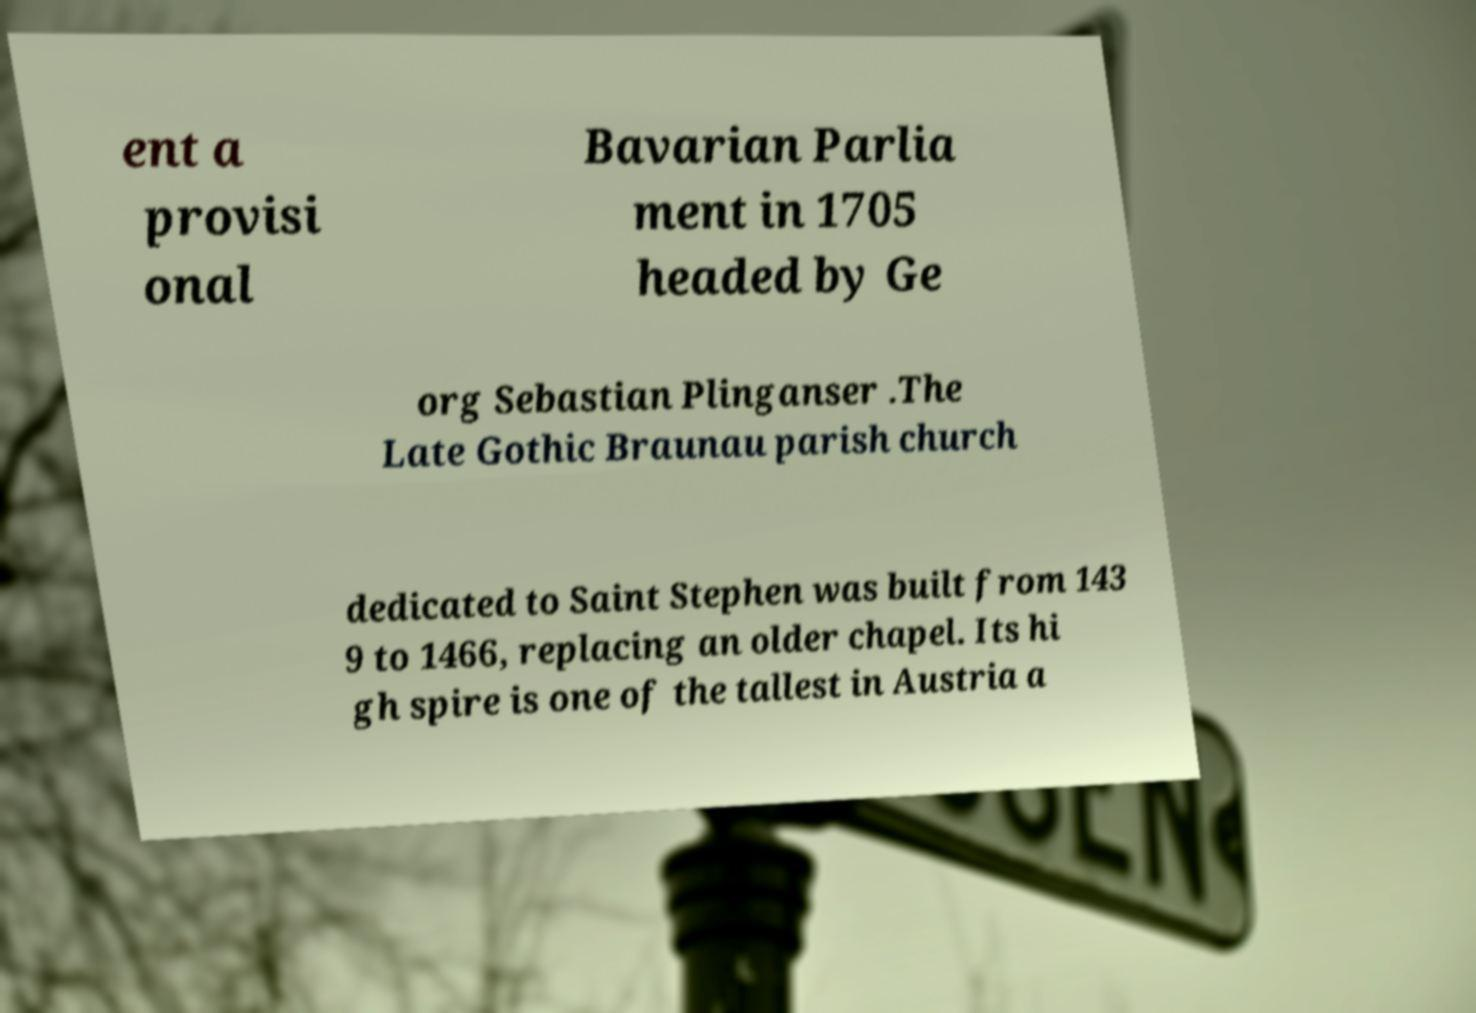There's text embedded in this image that I need extracted. Can you transcribe it verbatim? ent a provisi onal Bavarian Parlia ment in 1705 headed by Ge org Sebastian Plinganser .The Late Gothic Braunau parish church dedicated to Saint Stephen was built from 143 9 to 1466, replacing an older chapel. Its hi gh spire is one of the tallest in Austria a 